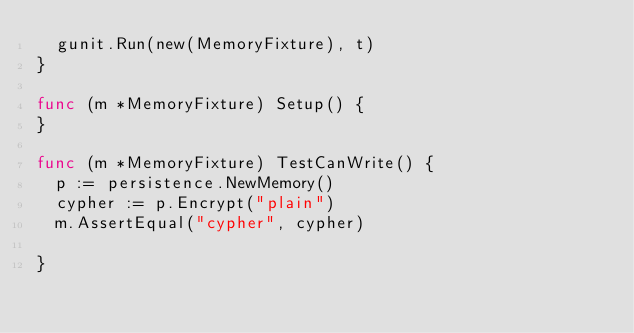<code> <loc_0><loc_0><loc_500><loc_500><_Go_>	gunit.Run(new(MemoryFixture), t)
}

func (m *MemoryFixture) Setup() {
}

func (m *MemoryFixture) TestCanWrite() {
	p := persistence.NewMemory()
	cypher := p.Encrypt("plain")
	m.AssertEqual("cypher", cypher)

}
</code> 